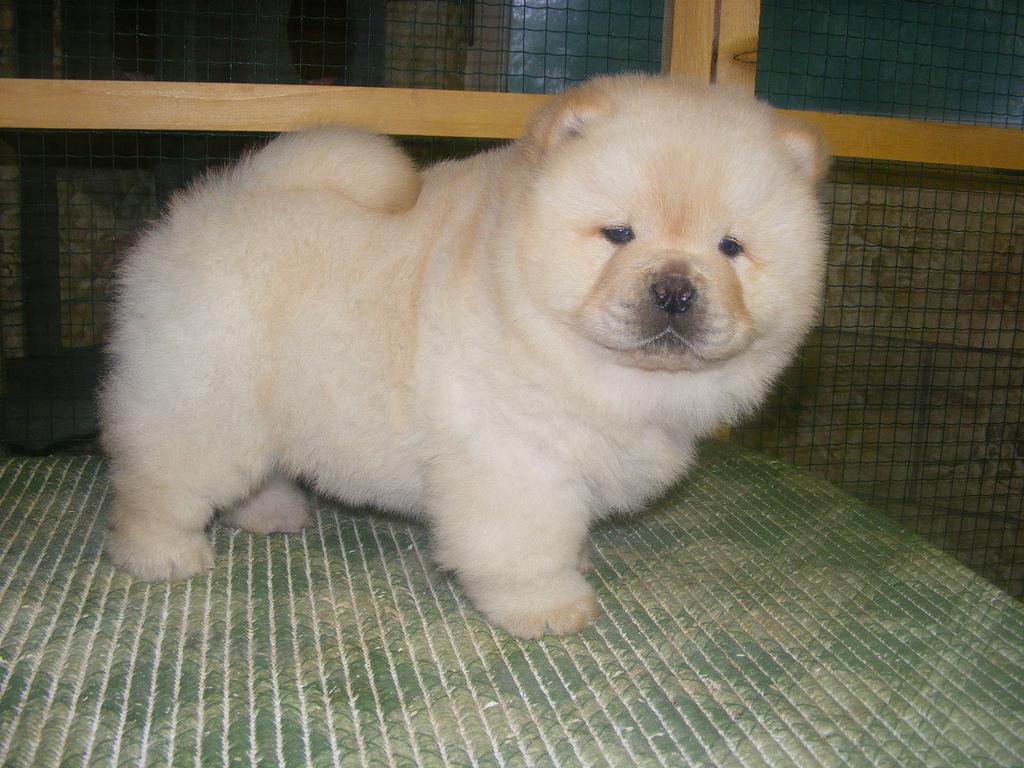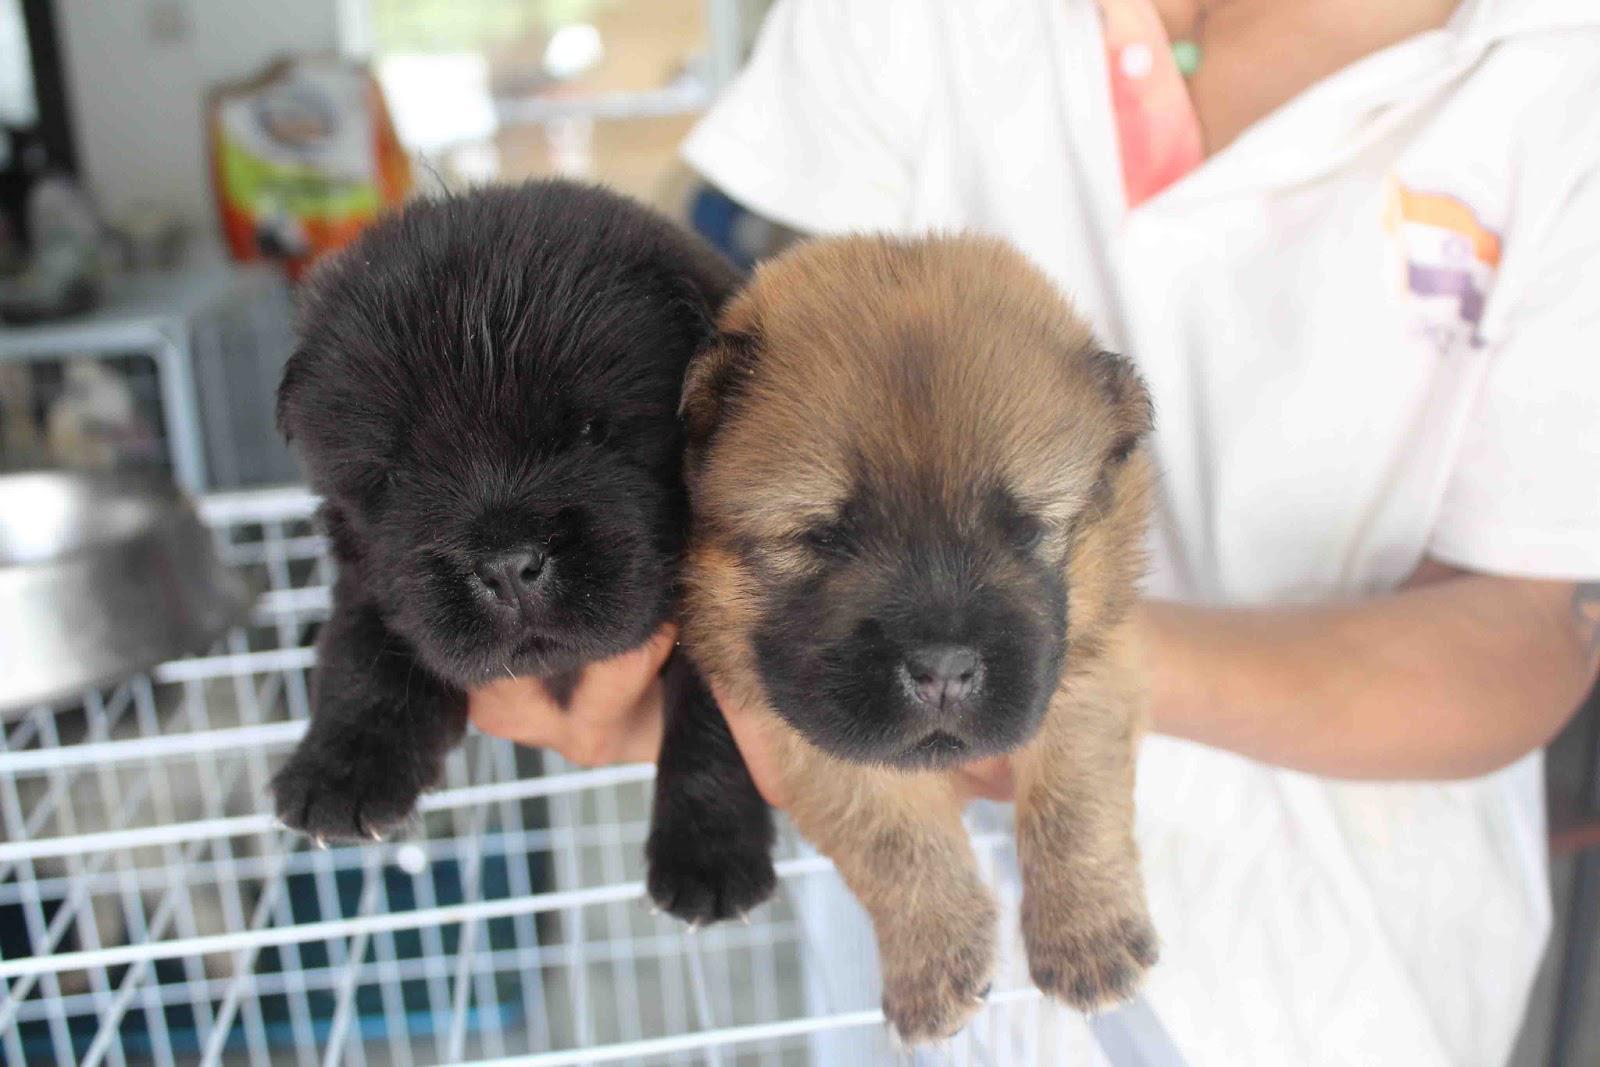The first image is the image on the left, the second image is the image on the right. For the images shown, is this caption "At least one image shows a cream-colored chow puppy posed on a solid blue, non-textured surface outdoors." true? Answer yes or no. No. The first image is the image on the left, the second image is the image on the right. Analyze the images presented: Is the assertion "The dog in the image on the left is outside on a blue mat." valid? Answer yes or no. No. 